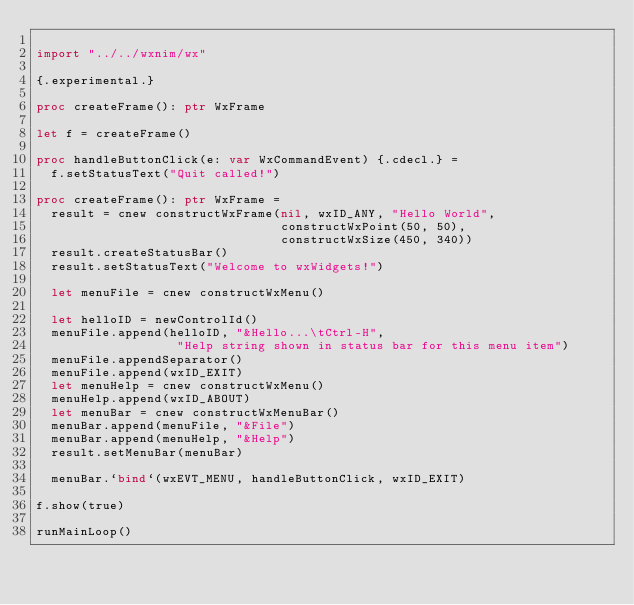Convert code to text. <code><loc_0><loc_0><loc_500><loc_500><_Nim_>
import "../../wxnim/wx"

{.experimental.}

proc createFrame(): ptr WxFrame

let f = createFrame()

proc handleButtonClick(e: var WxCommandEvent) {.cdecl.} =
  f.setStatusText("Quit called!")

proc createFrame(): ptr WxFrame =
  result = cnew constructWxFrame(nil, wxID_ANY, "Hello World",
                                 constructWxPoint(50, 50),
                                 constructWxSize(450, 340))
  result.createStatusBar()
  result.setStatusText("Welcome to wxWidgets!")

  let menuFile = cnew constructWxMenu()

  let helloID = newControlId()
  menuFile.append(helloID, "&Hello...\tCtrl-H",
                   "Help string shown in status bar for this menu item")
  menuFile.appendSeparator()
  menuFile.append(wxID_EXIT)
  let menuHelp = cnew constructWxMenu()
  menuHelp.append(wxID_ABOUT)
  let menuBar = cnew constructWxMenuBar()
  menuBar.append(menuFile, "&File")
  menuBar.append(menuHelp, "&Help")
  result.setMenuBar(menuBar)

  menuBar.`bind`(wxEVT_MENU, handleButtonClick, wxID_EXIT)

f.show(true)

runMainLoop()
</code> 